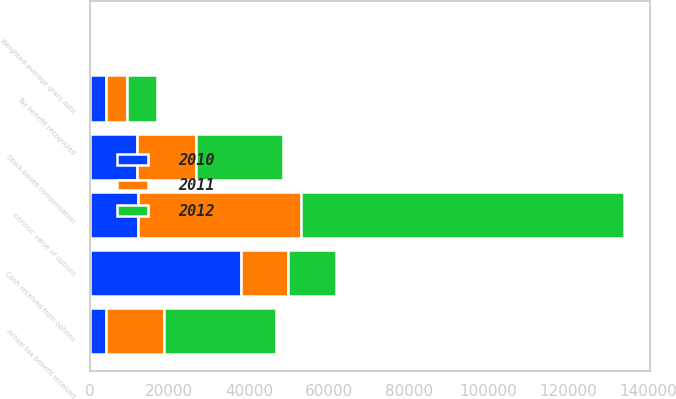Convert chart. <chart><loc_0><loc_0><loc_500><loc_500><stacked_bar_chart><ecel><fcel>Stock-based compensation<fcel>Tax benefit recognized<fcel>Weighted-average grant-date<fcel>Intrinsic value of options<fcel>Cash received from options<fcel>Actual tax benefit received<nl><fcel>2012<fcel>21605<fcel>7562<fcel>15.7<fcel>80781<fcel>11975<fcel>28086<nl><fcel>2011<fcel>14954<fcel>5234<fcel>15.48<fcel>40991<fcel>11975<fcel>14347<nl><fcel>2010<fcel>11848<fcel>4147<fcel>10.35<fcel>12102<fcel>37863<fcel>4236<nl></chart> 